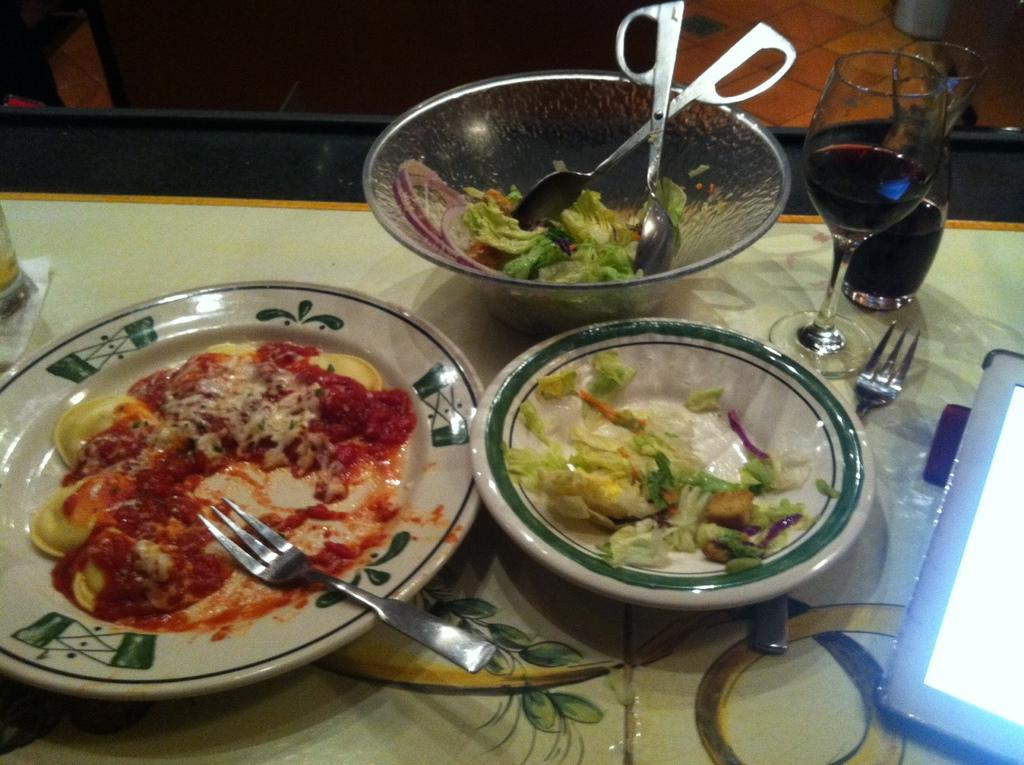What can be seen on the plates in the image? There are food plates with food in the image. What are the glasses on the table holding? There are glasses with drinks in the image. What utensils are visible in the image? Forks and spoons are present in the image. What other objects can be seen on the table in the image? There are other objects on the table in the image. What type of soda is being measured in the image? There is no soda or measuring device present in the image. 